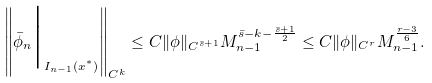<formula> <loc_0><loc_0><loc_500><loc_500>\left \| \bar { \phi } _ { n } \Big | _ { I _ { n - 1 } ( x ^ { ^ { * } } ) } \right \| _ { C ^ { k } } \leq C \| \phi \| _ { C ^ { \bar { s } + 1 } } M _ { n - 1 } ^ { \bar { s } - k - \frac { \bar { s } + 1 } { 2 } } \leq C \| \phi \| _ { C ^ { r } } M _ { n - 1 } ^ { \frac { r - 3 } { 6 } } .</formula> 